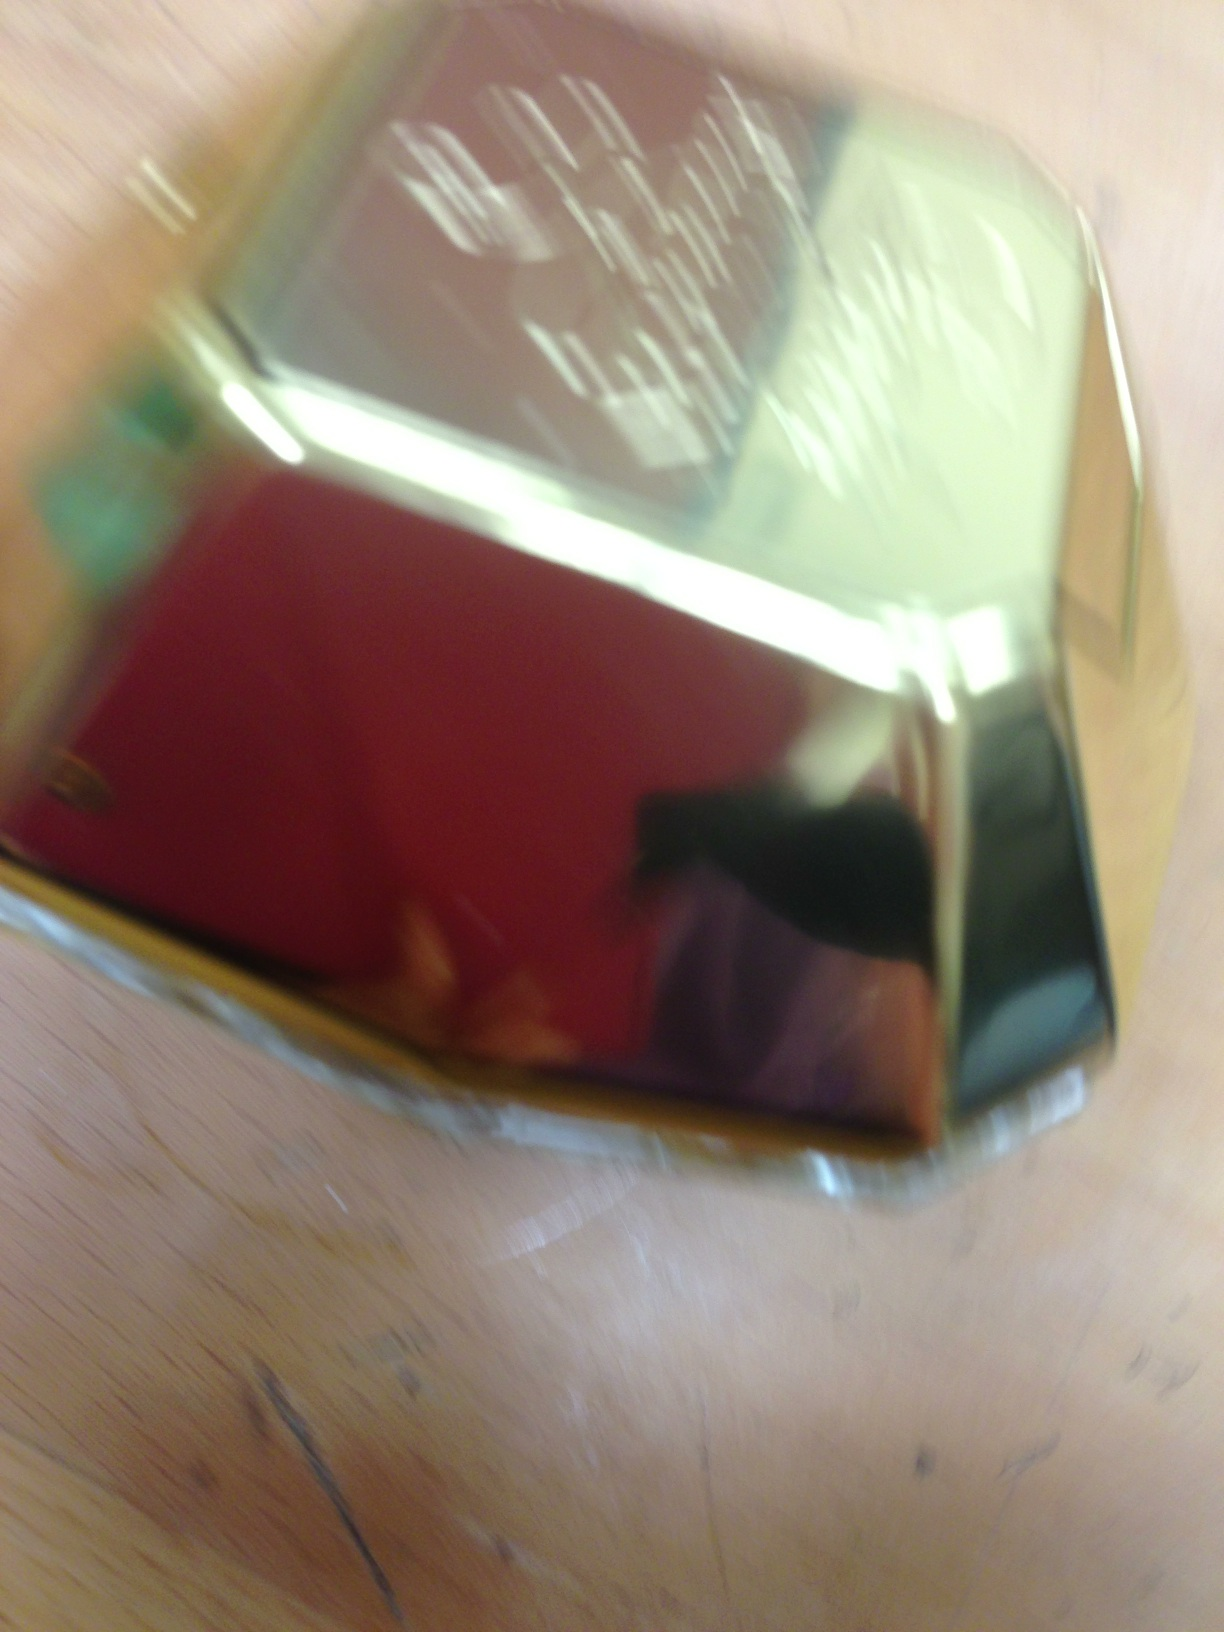Where might someone have bought this perfume? This perfume could have been purchased at an upscale boutique or a high-end department store specializing in exclusive and luxurious fragrances.  Describe the packaging of this perfume if presented as a gift. Imagining it as a gift, this perfume would likely be nestled in a beautifully crafted box with elegant satin linings, perhaps with intricate gold detailing. The exterior might have a sleek, matte finish with embossed lettering, adding an air of exclusivity and sophistication. 